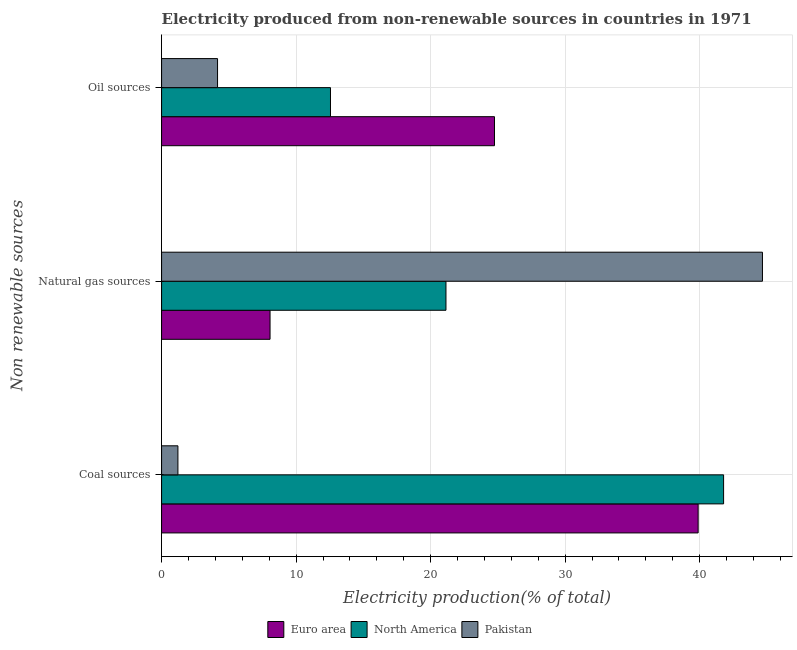How many different coloured bars are there?
Keep it short and to the point. 3. How many groups of bars are there?
Your response must be concise. 3. Are the number of bars on each tick of the Y-axis equal?
Offer a terse response. Yes. What is the label of the 1st group of bars from the top?
Offer a terse response. Oil sources. What is the percentage of electricity produced by coal in North America?
Make the answer very short. 41.78. Across all countries, what is the maximum percentage of electricity produced by coal?
Make the answer very short. 41.78. Across all countries, what is the minimum percentage of electricity produced by oil sources?
Your answer should be compact. 4.16. What is the total percentage of electricity produced by oil sources in the graph?
Provide a succinct answer. 41.46. What is the difference between the percentage of electricity produced by coal in North America and that in Pakistan?
Keep it short and to the point. 40.56. What is the difference between the percentage of electricity produced by natural gas in North America and the percentage of electricity produced by coal in Pakistan?
Your response must be concise. 19.92. What is the average percentage of electricity produced by coal per country?
Keep it short and to the point. 27.63. What is the difference between the percentage of electricity produced by coal and percentage of electricity produced by natural gas in North America?
Provide a succinct answer. 20.64. In how many countries, is the percentage of electricity produced by oil sources greater than 30 %?
Your response must be concise. 0. What is the ratio of the percentage of electricity produced by oil sources in North America to that in Pakistan?
Offer a terse response. 3.02. Is the difference between the percentage of electricity produced by natural gas in Pakistan and Euro area greater than the difference between the percentage of electricity produced by coal in Pakistan and Euro area?
Give a very brief answer. Yes. What is the difference between the highest and the second highest percentage of electricity produced by coal?
Keep it short and to the point. 1.89. What is the difference between the highest and the lowest percentage of electricity produced by oil sources?
Your answer should be very brief. 20.59. In how many countries, is the percentage of electricity produced by oil sources greater than the average percentage of electricity produced by oil sources taken over all countries?
Offer a terse response. 1. Is it the case that in every country, the sum of the percentage of electricity produced by coal and percentage of electricity produced by natural gas is greater than the percentage of electricity produced by oil sources?
Provide a short and direct response. Yes. How many bars are there?
Your response must be concise. 9. Are all the bars in the graph horizontal?
Give a very brief answer. Yes. How many countries are there in the graph?
Your response must be concise. 3. What is the difference between two consecutive major ticks on the X-axis?
Offer a terse response. 10. Does the graph contain any zero values?
Give a very brief answer. No. Where does the legend appear in the graph?
Your answer should be compact. Bottom center. What is the title of the graph?
Offer a terse response. Electricity produced from non-renewable sources in countries in 1971. Does "Peru" appear as one of the legend labels in the graph?
Your answer should be very brief. No. What is the label or title of the Y-axis?
Offer a very short reply. Non renewable sources. What is the Electricity production(% of total) in Euro area in Coal sources?
Give a very brief answer. 39.88. What is the Electricity production(% of total) of North America in Coal sources?
Your answer should be compact. 41.78. What is the Electricity production(% of total) in Pakistan in Coal sources?
Make the answer very short. 1.22. What is the Electricity production(% of total) in Euro area in Natural gas sources?
Provide a succinct answer. 8.06. What is the Electricity production(% of total) in North America in Natural gas sources?
Your answer should be compact. 21.14. What is the Electricity production(% of total) in Pakistan in Natural gas sources?
Offer a terse response. 44.66. What is the Electricity production(% of total) in Euro area in Oil sources?
Make the answer very short. 24.75. What is the Electricity production(% of total) of North America in Oil sources?
Offer a very short reply. 12.56. What is the Electricity production(% of total) of Pakistan in Oil sources?
Your response must be concise. 4.16. Across all Non renewable sources, what is the maximum Electricity production(% of total) in Euro area?
Provide a succinct answer. 39.88. Across all Non renewable sources, what is the maximum Electricity production(% of total) in North America?
Your answer should be very brief. 41.78. Across all Non renewable sources, what is the maximum Electricity production(% of total) in Pakistan?
Offer a very short reply. 44.66. Across all Non renewable sources, what is the minimum Electricity production(% of total) in Euro area?
Provide a succinct answer. 8.06. Across all Non renewable sources, what is the minimum Electricity production(% of total) of North America?
Your response must be concise. 12.56. Across all Non renewable sources, what is the minimum Electricity production(% of total) in Pakistan?
Your response must be concise. 1.22. What is the total Electricity production(% of total) of Euro area in the graph?
Make the answer very short. 72.69. What is the total Electricity production(% of total) in North America in the graph?
Your answer should be compact. 75.47. What is the total Electricity production(% of total) in Pakistan in the graph?
Keep it short and to the point. 50.04. What is the difference between the Electricity production(% of total) in Euro area in Coal sources and that in Natural gas sources?
Your answer should be very brief. 31.82. What is the difference between the Electricity production(% of total) in North America in Coal sources and that in Natural gas sources?
Offer a very short reply. 20.64. What is the difference between the Electricity production(% of total) in Pakistan in Coal sources and that in Natural gas sources?
Your answer should be very brief. -43.45. What is the difference between the Electricity production(% of total) in Euro area in Coal sources and that in Oil sources?
Keep it short and to the point. 15.14. What is the difference between the Electricity production(% of total) of North America in Coal sources and that in Oil sources?
Provide a short and direct response. 29.22. What is the difference between the Electricity production(% of total) of Pakistan in Coal sources and that in Oil sources?
Keep it short and to the point. -2.95. What is the difference between the Electricity production(% of total) in Euro area in Natural gas sources and that in Oil sources?
Provide a succinct answer. -16.68. What is the difference between the Electricity production(% of total) in North America in Natural gas sources and that in Oil sources?
Give a very brief answer. 8.58. What is the difference between the Electricity production(% of total) of Pakistan in Natural gas sources and that in Oil sources?
Keep it short and to the point. 40.5. What is the difference between the Electricity production(% of total) of Euro area in Coal sources and the Electricity production(% of total) of North America in Natural gas sources?
Offer a terse response. 18.75. What is the difference between the Electricity production(% of total) in Euro area in Coal sources and the Electricity production(% of total) in Pakistan in Natural gas sources?
Your answer should be very brief. -4.78. What is the difference between the Electricity production(% of total) of North America in Coal sources and the Electricity production(% of total) of Pakistan in Natural gas sources?
Offer a very short reply. -2.89. What is the difference between the Electricity production(% of total) of Euro area in Coal sources and the Electricity production(% of total) of North America in Oil sources?
Your answer should be very brief. 27.33. What is the difference between the Electricity production(% of total) in Euro area in Coal sources and the Electricity production(% of total) in Pakistan in Oil sources?
Provide a short and direct response. 35.72. What is the difference between the Electricity production(% of total) of North America in Coal sources and the Electricity production(% of total) of Pakistan in Oil sources?
Provide a short and direct response. 37.62. What is the difference between the Electricity production(% of total) of Euro area in Natural gas sources and the Electricity production(% of total) of North America in Oil sources?
Provide a succinct answer. -4.49. What is the difference between the Electricity production(% of total) of Euro area in Natural gas sources and the Electricity production(% of total) of Pakistan in Oil sources?
Provide a succinct answer. 3.9. What is the difference between the Electricity production(% of total) of North America in Natural gas sources and the Electricity production(% of total) of Pakistan in Oil sources?
Provide a short and direct response. 16.98. What is the average Electricity production(% of total) of Euro area per Non renewable sources?
Keep it short and to the point. 24.23. What is the average Electricity production(% of total) of North America per Non renewable sources?
Make the answer very short. 25.16. What is the average Electricity production(% of total) of Pakistan per Non renewable sources?
Ensure brevity in your answer.  16.68. What is the difference between the Electricity production(% of total) in Euro area and Electricity production(% of total) in North America in Coal sources?
Give a very brief answer. -1.89. What is the difference between the Electricity production(% of total) of Euro area and Electricity production(% of total) of Pakistan in Coal sources?
Provide a succinct answer. 38.67. What is the difference between the Electricity production(% of total) in North America and Electricity production(% of total) in Pakistan in Coal sources?
Ensure brevity in your answer.  40.56. What is the difference between the Electricity production(% of total) in Euro area and Electricity production(% of total) in North America in Natural gas sources?
Keep it short and to the point. -13.08. What is the difference between the Electricity production(% of total) of Euro area and Electricity production(% of total) of Pakistan in Natural gas sources?
Keep it short and to the point. -36.6. What is the difference between the Electricity production(% of total) in North America and Electricity production(% of total) in Pakistan in Natural gas sources?
Your answer should be very brief. -23.52. What is the difference between the Electricity production(% of total) in Euro area and Electricity production(% of total) in North America in Oil sources?
Your answer should be compact. 12.19. What is the difference between the Electricity production(% of total) in Euro area and Electricity production(% of total) in Pakistan in Oil sources?
Keep it short and to the point. 20.59. What is the difference between the Electricity production(% of total) of North America and Electricity production(% of total) of Pakistan in Oil sources?
Your response must be concise. 8.4. What is the ratio of the Electricity production(% of total) in Euro area in Coal sources to that in Natural gas sources?
Offer a terse response. 4.95. What is the ratio of the Electricity production(% of total) in North America in Coal sources to that in Natural gas sources?
Your response must be concise. 1.98. What is the ratio of the Electricity production(% of total) in Pakistan in Coal sources to that in Natural gas sources?
Your answer should be compact. 0.03. What is the ratio of the Electricity production(% of total) of Euro area in Coal sources to that in Oil sources?
Keep it short and to the point. 1.61. What is the ratio of the Electricity production(% of total) in North America in Coal sources to that in Oil sources?
Offer a terse response. 3.33. What is the ratio of the Electricity production(% of total) of Pakistan in Coal sources to that in Oil sources?
Your response must be concise. 0.29. What is the ratio of the Electricity production(% of total) in Euro area in Natural gas sources to that in Oil sources?
Ensure brevity in your answer.  0.33. What is the ratio of the Electricity production(% of total) of North America in Natural gas sources to that in Oil sources?
Your response must be concise. 1.68. What is the ratio of the Electricity production(% of total) of Pakistan in Natural gas sources to that in Oil sources?
Give a very brief answer. 10.74. What is the difference between the highest and the second highest Electricity production(% of total) in Euro area?
Provide a short and direct response. 15.14. What is the difference between the highest and the second highest Electricity production(% of total) of North America?
Provide a short and direct response. 20.64. What is the difference between the highest and the second highest Electricity production(% of total) of Pakistan?
Your answer should be compact. 40.5. What is the difference between the highest and the lowest Electricity production(% of total) in Euro area?
Provide a succinct answer. 31.82. What is the difference between the highest and the lowest Electricity production(% of total) in North America?
Provide a succinct answer. 29.22. What is the difference between the highest and the lowest Electricity production(% of total) of Pakistan?
Offer a very short reply. 43.45. 